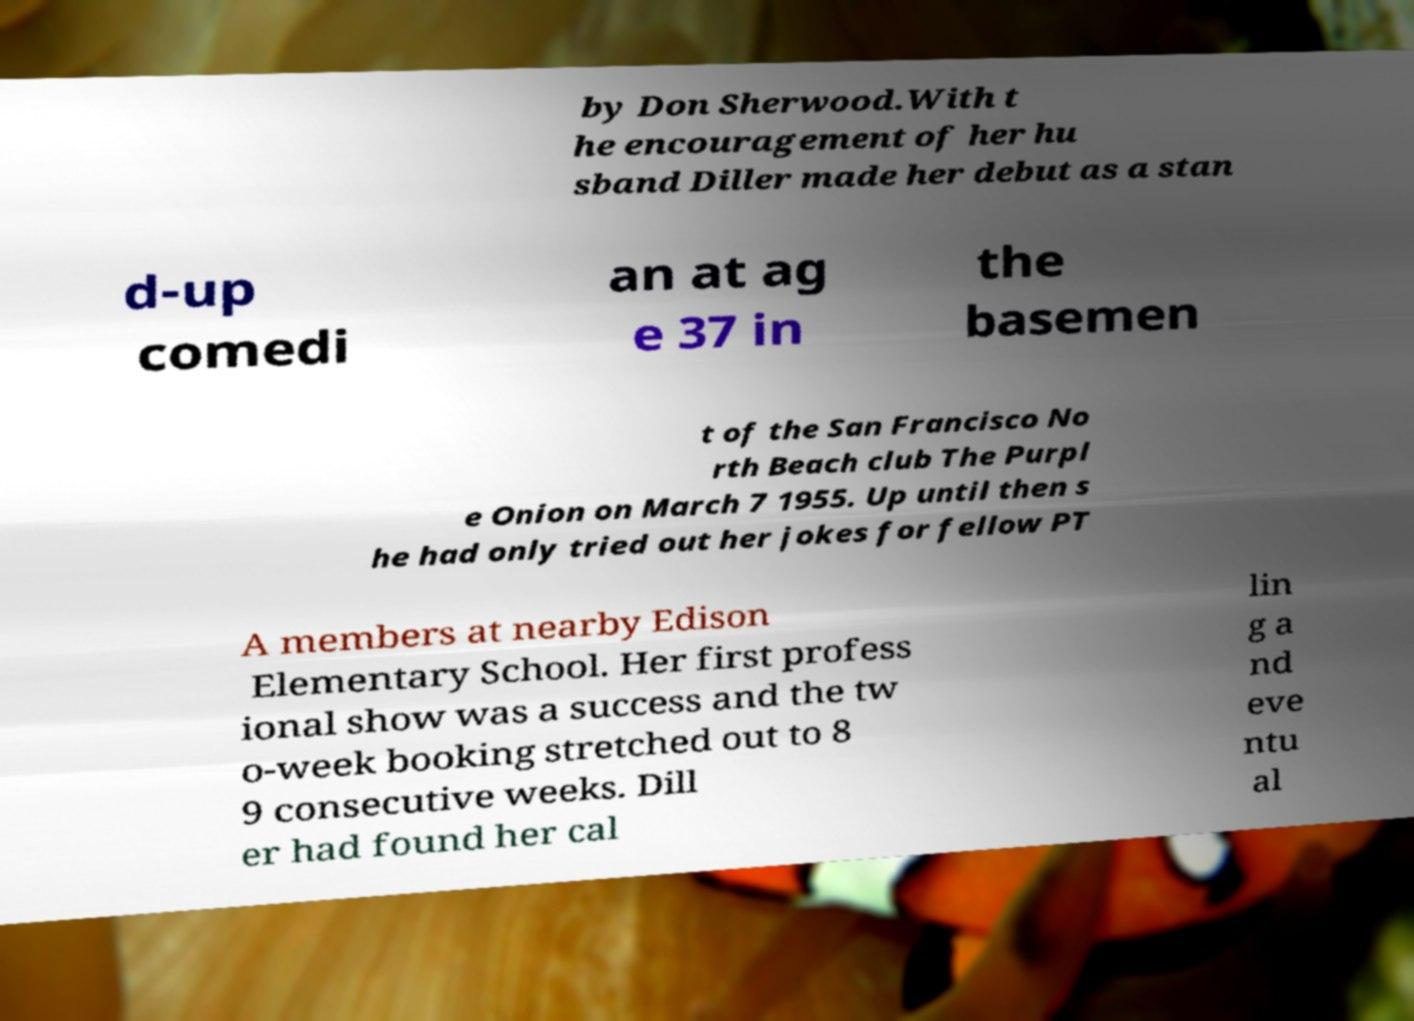There's text embedded in this image that I need extracted. Can you transcribe it verbatim? by Don Sherwood.With t he encouragement of her hu sband Diller made her debut as a stan d-up comedi an at ag e 37 in the basemen t of the San Francisco No rth Beach club The Purpl e Onion on March 7 1955. Up until then s he had only tried out her jokes for fellow PT A members at nearby Edison Elementary School. Her first profess ional show was a success and the tw o-week booking stretched out to 8 9 consecutive weeks. Dill er had found her cal lin g a nd eve ntu al 